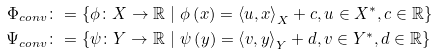Convert formula to latex. <formula><loc_0><loc_0><loc_500><loc_500>\Phi _ { c o n v } & \colon = \left \{ \phi \colon X \to \mathbb { R } \ | \ \phi \left ( x \right ) = \left \langle u , x \right \rangle _ { X } + c , u \in X ^ { * } , c \in \mathbb { R } \right \} \\ \Psi _ { c o n v } & \colon = \left \{ \psi \colon Y \to \mathbb { R } \ | \ \psi \left ( y \right ) = \left \langle v , y \right \rangle _ { Y } + d , v \in Y ^ { * } , d \in \mathbb { R } \right \}</formula> 